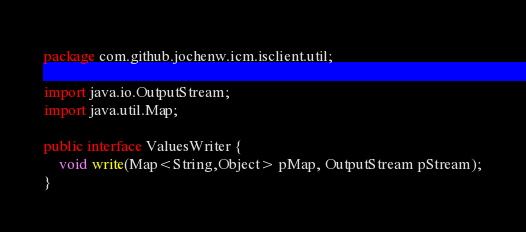<code> <loc_0><loc_0><loc_500><loc_500><_Java_>package com.github.jochenw.icm.isclient.util;

import java.io.OutputStream;
import java.util.Map;

public interface ValuesWriter {
	void write(Map<String,Object> pMap, OutputStream pStream);
}
</code> 